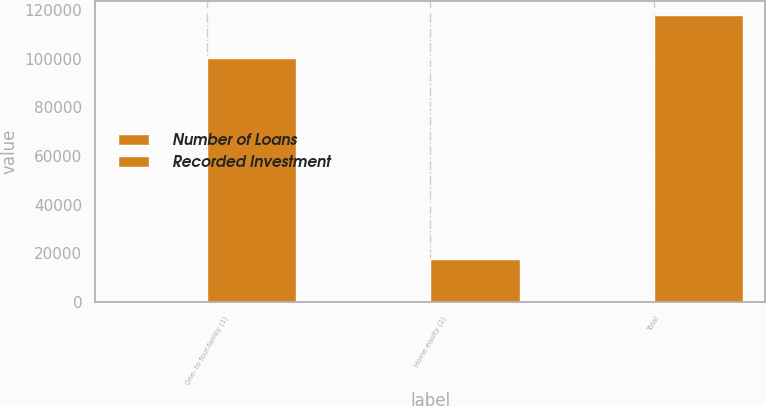Convert chart. <chart><loc_0><loc_0><loc_500><loc_500><stacked_bar_chart><ecel><fcel>One- to four-family (1)<fcel>Home equity (2)<fcel>Total<nl><fcel>Number of Loans<fcel>260<fcel>367<fcel>627<nl><fcel>Recorded Investment<fcel>100182<fcel>17809<fcel>117991<nl></chart> 